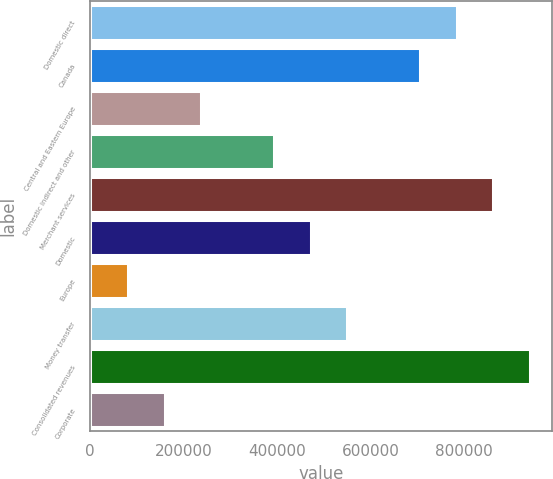Convert chart to OTSL. <chart><loc_0><loc_0><loc_500><loc_500><bar_chart><fcel>Domestic direct<fcel>Canada<fcel>Central and Eastern Europe<fcel>Domestic indirect and other<fcel>Merchant services<fcel>Domestic<fcel>Europe<fcel>Money transfer<fcel>Consolidated revenues<fcel>Corporate<nl><fcel>784331<fcel>706270<fcel>237908<fcel>394028<fcel>862392<fcel>472089<fcel>81786.5<fcel>550150<fcel>940452<fcel>159847<nl></chart> 